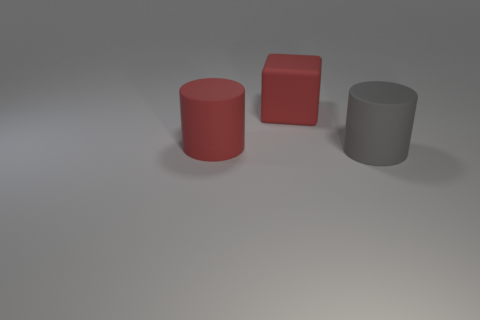What material is the cylinder that is the same color as the large block?
Provide a succinct answer. Rubber. The large thing that is on the right side of the thing behind the cylinder that is on the left side of the gray rubber cylinder is what color?
Provide a short and direct response. Gray. Does the rubber cylinder that is on the right side of the large red matte cylinder have the same color as the matte cylinder that is to the left of the large gray matte cylinder?
Make the answer very short. No. There is a large matte thing that is behind the big matte cylinder left of the gray rubber thing; what is its shape?
Offer a terse response. Cube. Are there any cyan balls that have the same size as the gray cylinder?
Provide a succinct answer. No. What number of other matte objects are the same shape as the big gray thing?
Offer a very short reply. 1. Are there an equal number of big red matte cubes that are behind the large red block and gray cylinders that are behind the large gray object?
Your answer should be very brief. Yes. Are any shiny blocks visible?
Your response must be concise. No. There is a cylinder that is left of the cylinder to the right of the big rubber cylinder that is to the left of the big gray object; what size is it?
Make the answer very short. Large. There is a gray matte object that is the same size as the block; what shape is it?
Provide a short and direct response. Cylinder. 